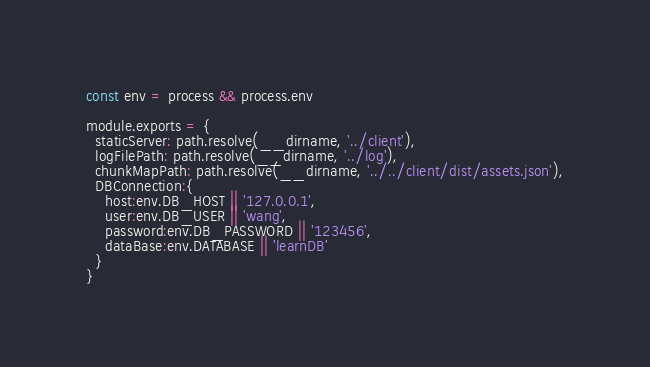Convert code to text. <code><loc_0><loc_0><loc_500><loc_500><_JavaScript_>const env = process && process.env

module.exports = {
  staticServer: path.resolve(__dirname, '../client'),
  logFilePath: path.resolve(__dirname, '../log'),
  chunkMapPath: path.resolve(__dirname, '../../client/dist/assets.json'),
  DBConnection:{
    host:env.DB_HOST || '127.0.0.1',
    user:env.DB_USER || 'wang',
    password:env.DB_PASSWORD || '123456',
    dataBase:env.DATABASE || 'learnDB'
  }
}
</code> 